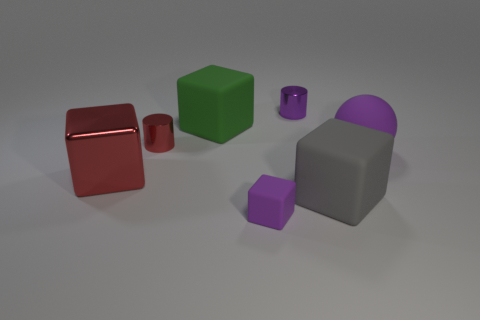Are there any cylinders?
Make the answer very short. Yes. What material is the sphere that is the same color as the tiny matte cube?
Your answer should be compact. Rubber. What number of things are large brown rubber cubes or cubes?
Your answer should be very brief. 4. Is there a large shiny thing of the same color as the matte ball?
Give a very brief answer. No. There is a big red thing behind the small cube; what number of blocks are in front of it?
Give a very brief answer. 2. Is the number of large brown cubes greater than the number of tiny purple cubes?
Your response must be concise. No. Do the red cube and the purple cylinder have the same material?
Ensure brevity in your answer.  Yes. Are there the same number of small purple metal cylinders on the right side of the large gray rubber block and big rubber objects?
Your answer should be very brief. No. What number of green cubes are made of the same material as the small red cylinder?
Give a very brief answer. 0. Is the number of purple rubber spheres less than the number of shiny cylinders?
Give a very brief answer. Yes. 